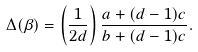<formula> <loc_0><loc_0><loc_500><loc_500>\Delta ( \beta ) = \left ( \frac { 1 } { 2 d } \right ) \frac { a + ( d - 1 ) c } { b + ( d - 1 ) c } .</formula> 